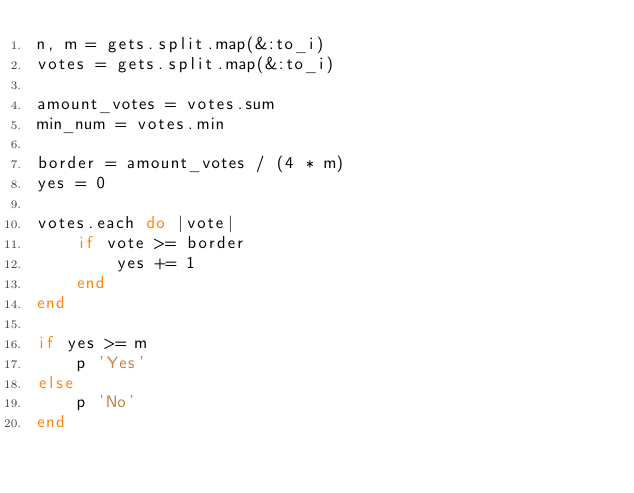Convert code to text. <code><loc_0><loc_0><loc_500><loc_500><_Ruby_>n, m = gets.split.map(&:to_i)
votes = gets.split.map(&:to_i)

amount_votes = votes.sum
min_num = votes.min

border = amount_votes / (4 * m)
yes = 0

votes.each do |vote|
    if vote >= border
        yes += 1
    end
end

if yes >= m
    p 'Yes'
else
    p 'No'
end
</code> 